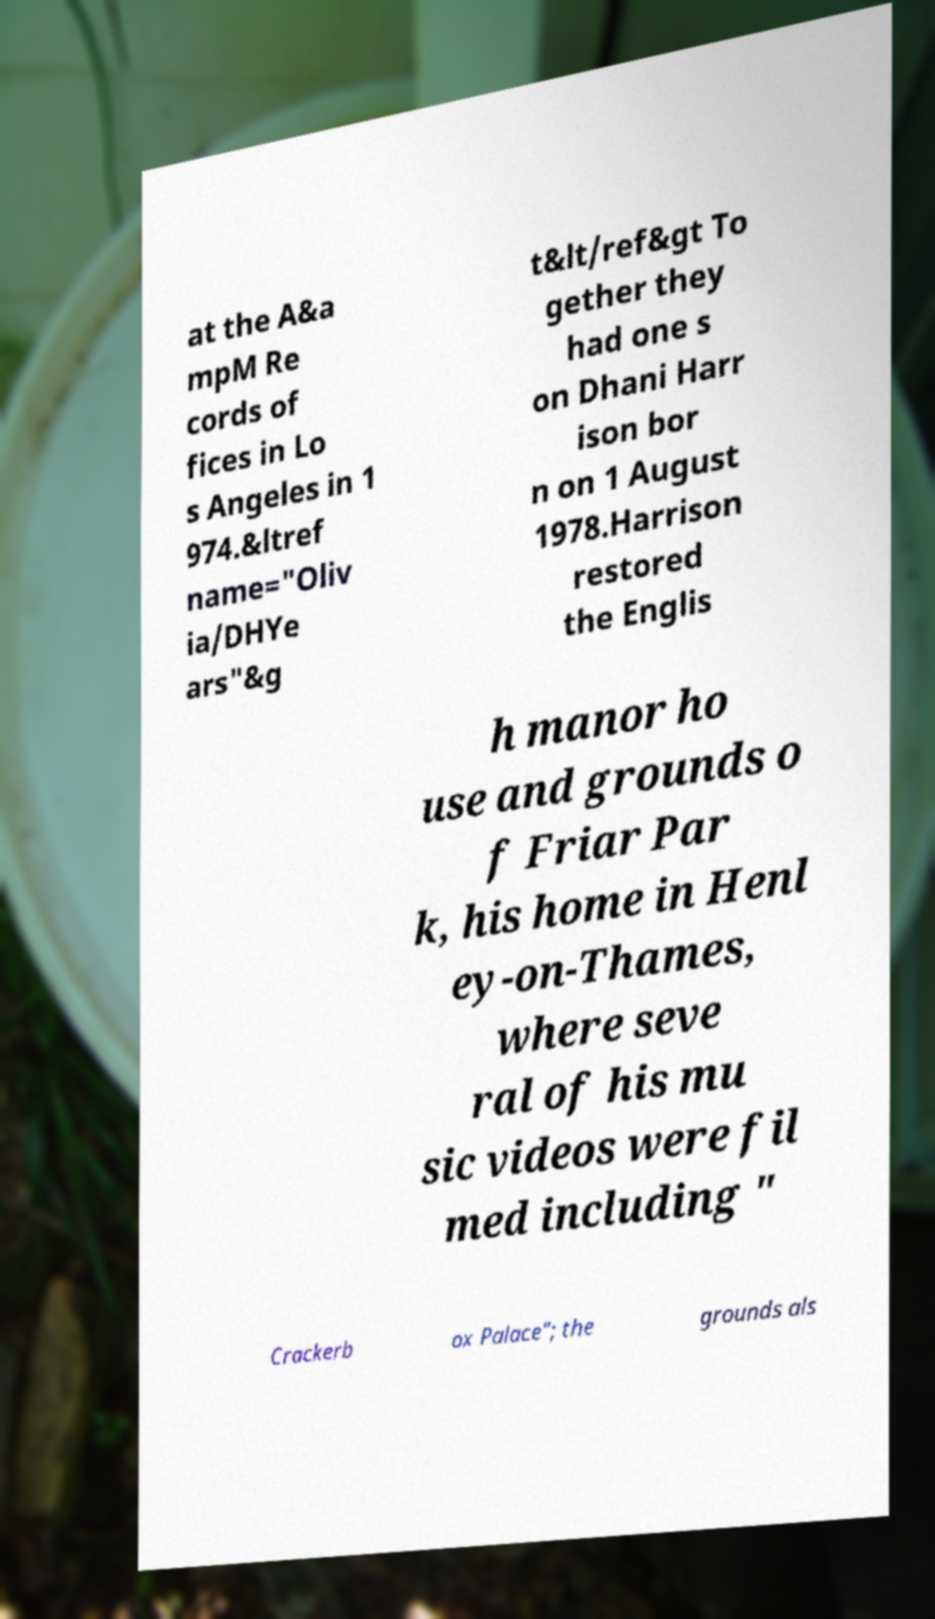For documentation purposes, I need the text within this image transcribed. Could you provide that? at the A&a mpM Re cords of fices in Lo s Angeles in 1 974.&ltref name="Oliv ia/DHYe ars"&g t&lt/ref&gt To gether they had one s on Dhani Harr ison bor n on 1 August 1978.Harrison restored the Englis h manor ho use and grounds o f Friar Par k, his home in Henl ey-on-Thames, where seve ral of his mu sic videos were fil med including " Crackerb ox Palace"; the grounds als 